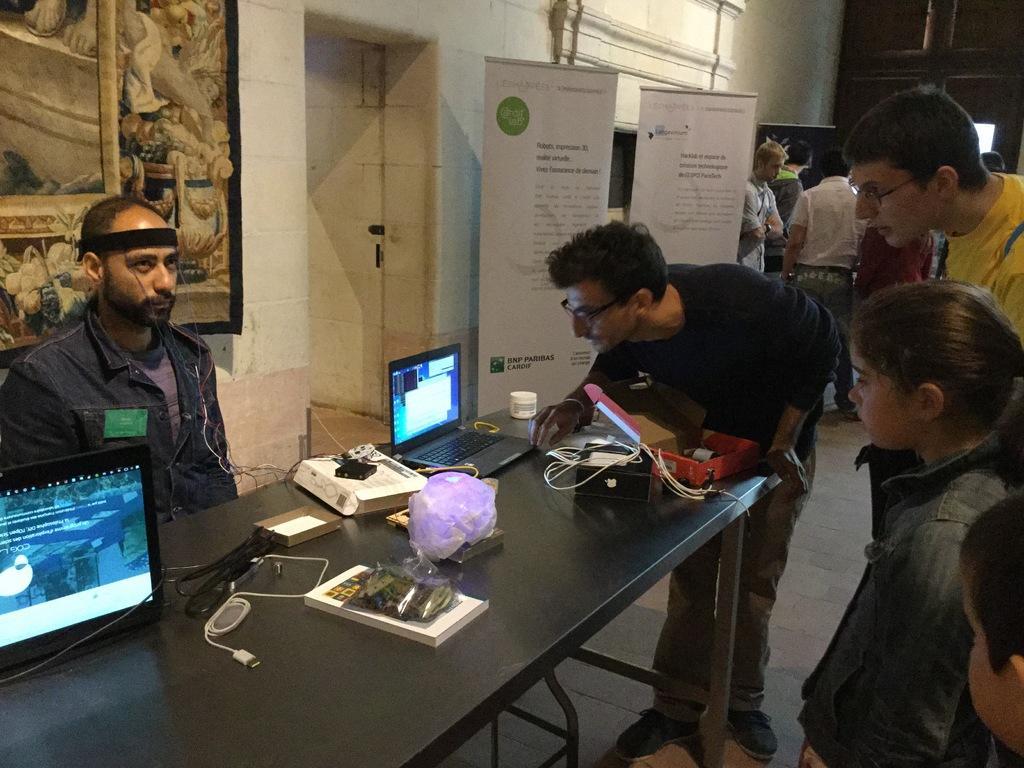Can you describe this image briefly? In the picture we can see some people standing and watching the laptop on the table and one person is sitting near the table in the background we can see a wall, painting and hoardings and some people standing. 